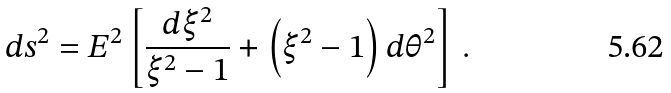<formula> <loc_0><loc_0><loc_500><loc_500>d s ^ { 2 } = E ^ { 2 } \left [ \frac { d { \xi } ^ { 2 } } { { \xi } ^ { 2 } - 1 } + \left ( \xi ^ { 2 } - 1 \right ) d { \theta } ^ { 2 } \right ] \, .</formula> 